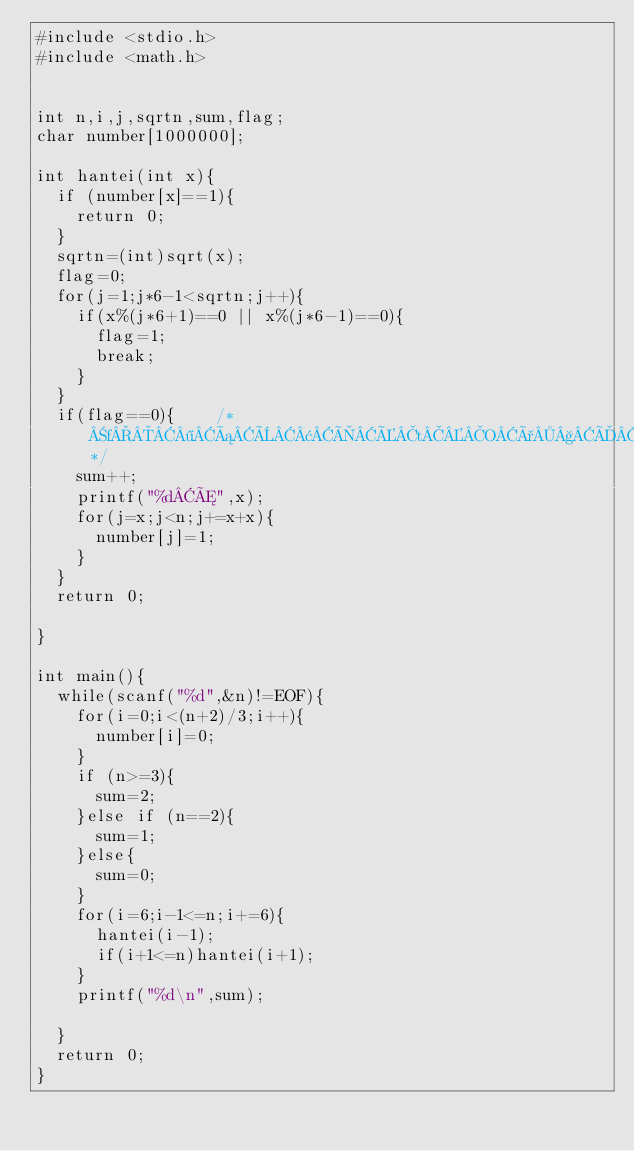Convert code to text. <code><loc_0><loc_0><loc_500><loc_500><_C_>#include <stdio.h>
#include <math.h>


int n,i,j,sqrtn,sum,flag;
char number[1000000];

int hantei(int x){
	if (number[x]==1){
		return 0;
	}
	sqrtn=(int)sqrt(x);
	flag=0;
	for(j=1;j*6-1<sqrtn;j++){
		if(x%(j*6+1)==0 || x%(j*6-1)==0){
			flag=1;
			break;
		}
	}
	if(flag==0){		/*f¶áÈ¢ÌÉtOð§ÄÄ­æ*/
		sum++;
		printf("%dÆ",x);
		for(j=x;j<n;j+=x+x){
			number[j]=1;
		}
	}
	return 0;

}

int main(){
	while(scanf("%d",&n)!=EOF){
		for(i=0;i<(n+2)/3;i++){
			number[i]=0;
		}
		if (n>=3){
			sum=2;
		}else if (n==2){
			sum=1;
		}else{
			sum=0;
		}
		for(i=6;i-1<=n;i+=6){
			hantei(i-1);
			if(i+1<=n)hantei(i+1);
		}
		printf("%d\n",sum);
		
	}
	return 0;
}</code> 